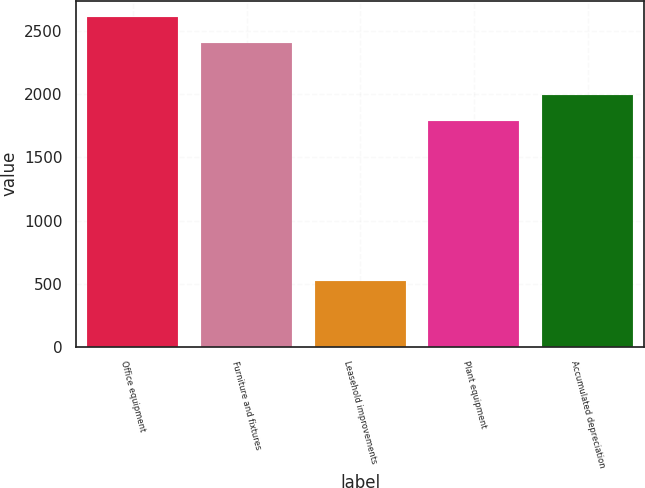Convert chart. <chart><loc_0><loc_0><loc_500><loc_500><bar_chart><fcel>Office equipment<fcel>Furniture and fixtures<fcel>Leasehold improvements<fcel>Plant equipment<fcel>Accumulated depreciation<nl><fcel>2612.9<fcel>2411<fcel>523<fcel>1792<fcel>1993.9<nl></chart> 